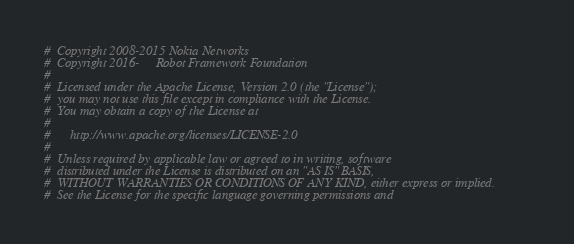Convert code to text. <code><loc_0><loc_0><loc_500><loc_500><_Python_>#  Copyright 2008-2015 Nokia Networks
#  Copyright 2016-     Robot Framework Foundation
#
#  Licensed under the Apache License, Version 2.0 (the "License");
#  you may not use this file except in compliance with the License.
#  You may obtain a copy of the License at
#
#      http://www.apache.org/licenses/LICENSE-2.0
#
#  Unless required by applicable law or agreed to in writing, software
#  distributed under the License is distributed on an "AS IS" BASIS,
#  WITHOUT WARRANTIES OR CONDITIONS OF ANY KIND, either express or implied.
#  See the License for the specific language governing permissions and</code> 